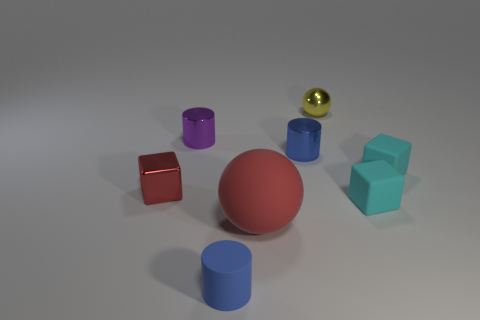Is there any other thing that has the same size as the matte ball?
Provide a succinct answer. No. Are there fewer tiny blocks in front of the red cube than small red things?
Make the answer very short. No. Does the metallic block have the same size as the red matte sphere?
Give a very brief answer. No. How many objects are either small blocks to the left of the yellow metal thing or green metal blocks?
Offer a very short reply. 1. What is the cylinder that is behind the blue thing behind the tiny red thing made of?
Make the answer very short. Metal. Are there any small yellow shiny objects of the same shape as the small purple metallic thing?
Your response must be concise. No. Does the purple thing have the same size as the sphere that is to the right of the big matte object?
Make the answer very short. Yes. How many things are tiny blocks that are right of the yellow sphere or rubber blocks that are in front of the tiny red cube?
Offer a terse response. 2. Is the number of tiny cyan matte cubes that are in front of the yellow metallic object greater than the number of small metallic balls?
Provide a short and direct response. Yes. What number of blue metallic cylinders are the same size as the red shiny object?
Keep it short and to the point. 1. 